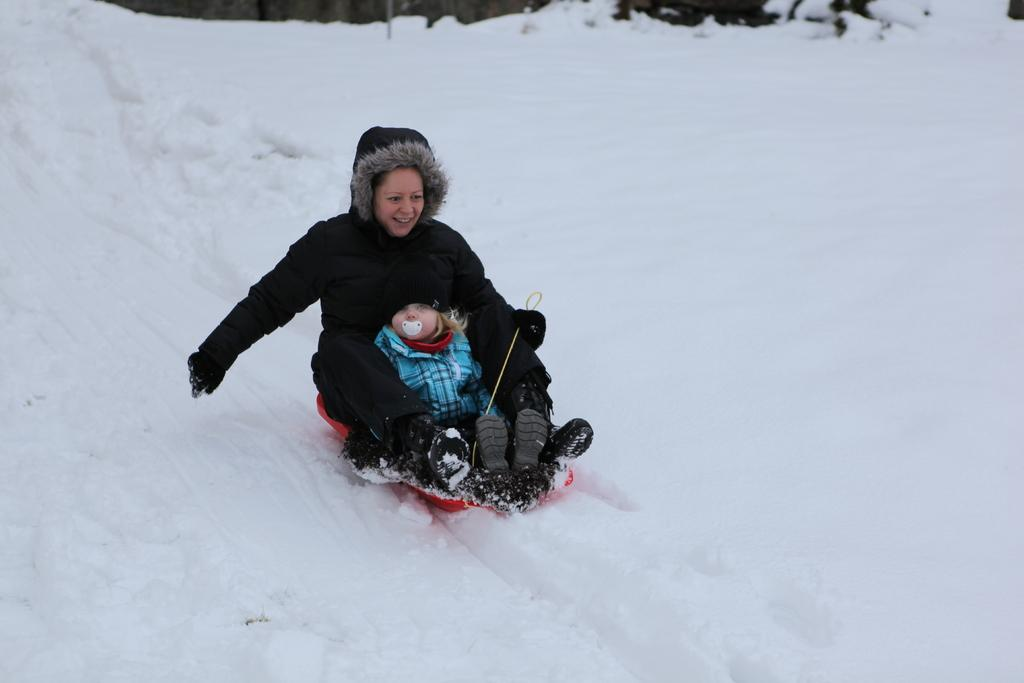What is the overall appearance of the image? The image is covered in snow. Can you identify any people in the image? Yes, there is a person in the image. Is the person alone in the image? No, the person is accompanied by a kid. What type of bell can be seen hanging from the tree in the image? There is no bell present in the image; it is covered in snow and features a person and a kid. 